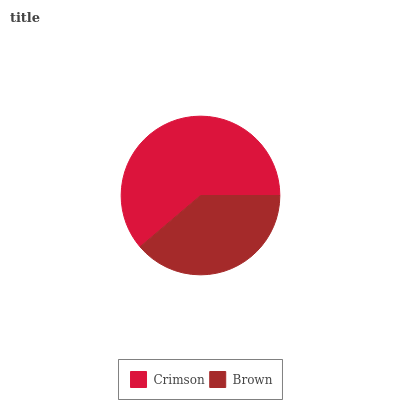Is Brown the minimum?
Answer yes or no. Yes. Is Crimson the maximum?
Answer yes or no. Yes. Is Brown the maximum?
Answer yes or no. No. Is Crimson greater than Brown?
Answer yes or no. Yes. Is Brown less than Crimson?
Answer yes or no. Yes. Is Brown greater than Crimson?
Answer yes or no. No. Is Crimson less than Brown?
Answer yes or no. No. Is Crimson the high median?
Answer yes or no. Yes. Is Brown the low median?
Answer yes or no. Yes. Is Brown the high median?
Answer yes or no. No. Is Crimson the low median?
Answer yes or no. No. 